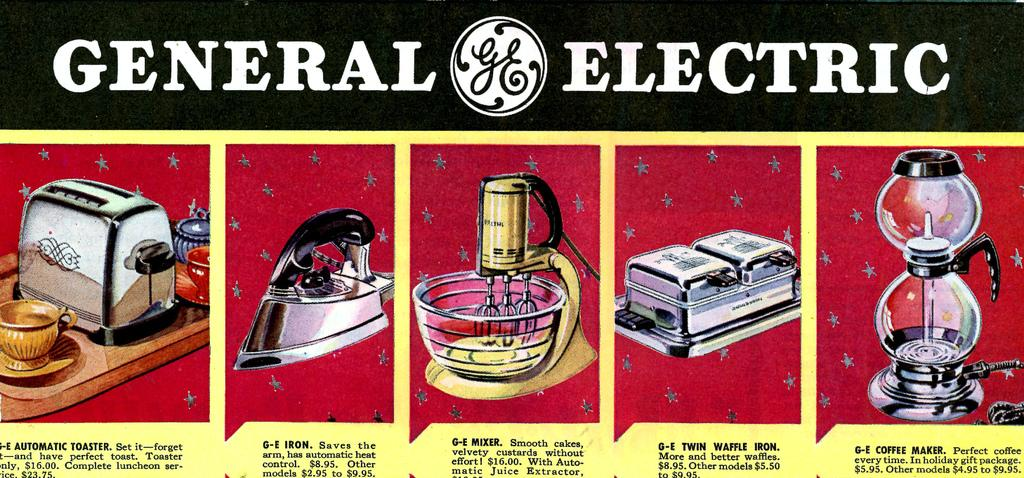<image>
Write a terse but informative summary of the picture. An advertisement for products from the company General Electric 